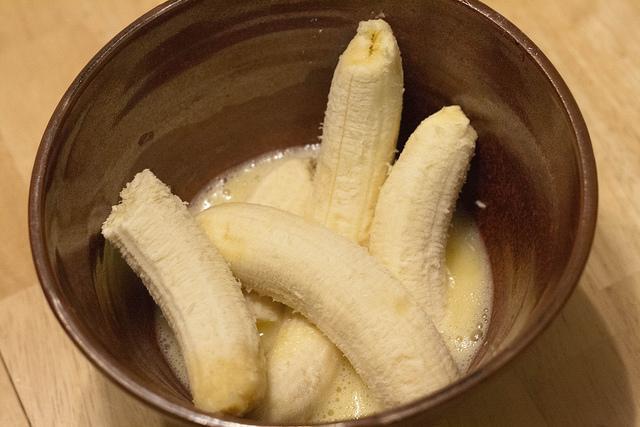How many dining tables are in the photo?
Give a very brief answer. 1. How many bananas can you see?
Give a very brief answer. 5. 